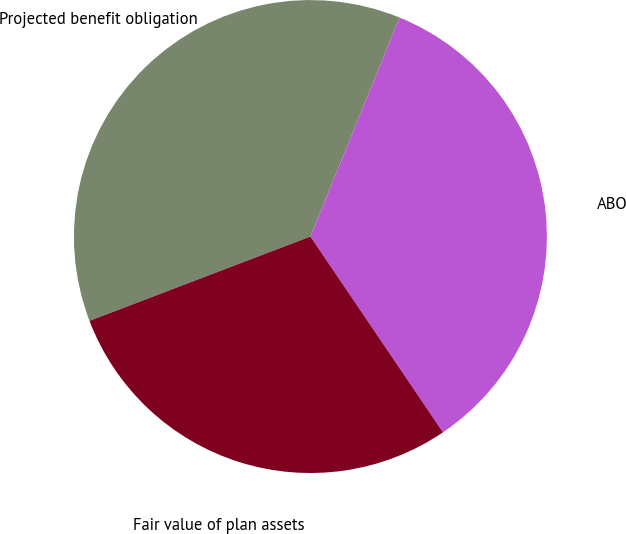<chart> <loc_0><loc_0><loc_500><loc_500><pie_chart><fcel>Projected benefit obligation<fcel>ABO<fcel>Fair value of plan assets<nl><fcel>36.96%<fcel>34.37%<fcel>28.67%<nl></chart> 